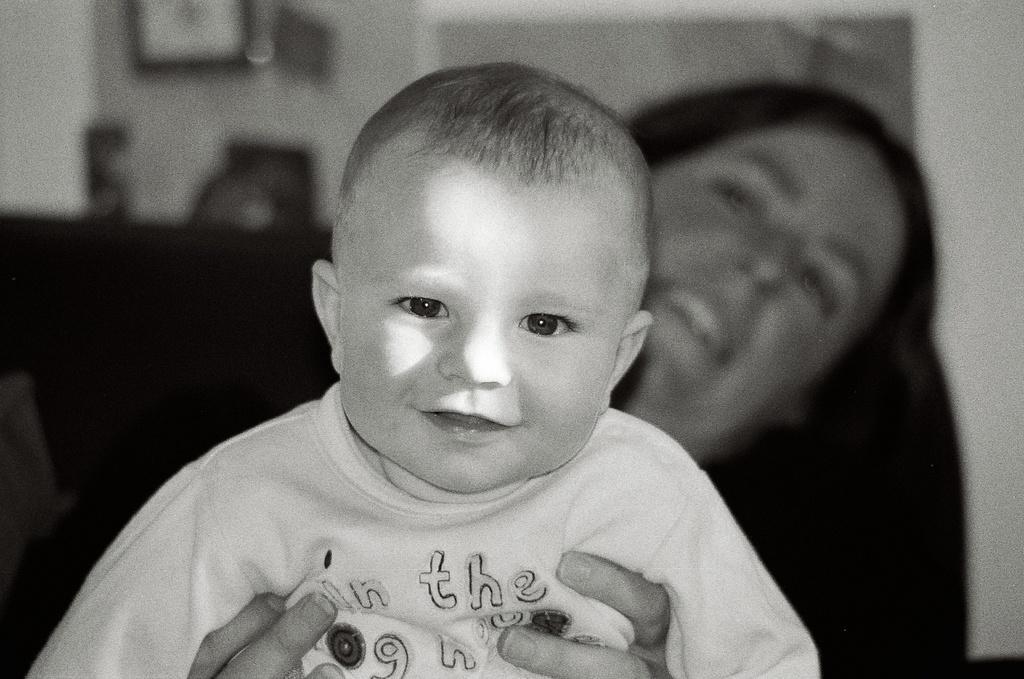In one or two sentences, can you explain what this image depicts? In this picture we can see a woman holding a boy. 